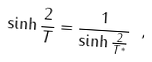<formula> <loc_0><loc_0><loc_500><loc_500>\sinh \frac { 2 } { T } = \frac { 1 } { \sinh \frac { 2 } { T ^ { * } } } \ ,</formula> 